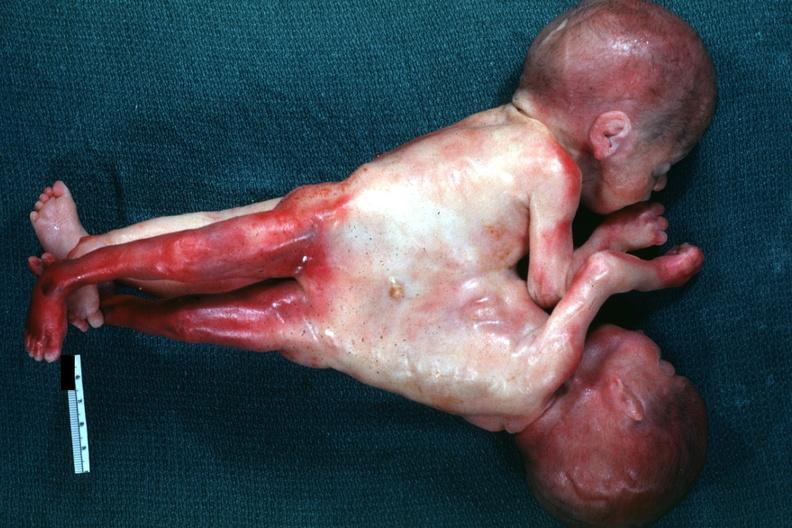s siamese twins present?
Answer the question using a single word or phrase. Yes 